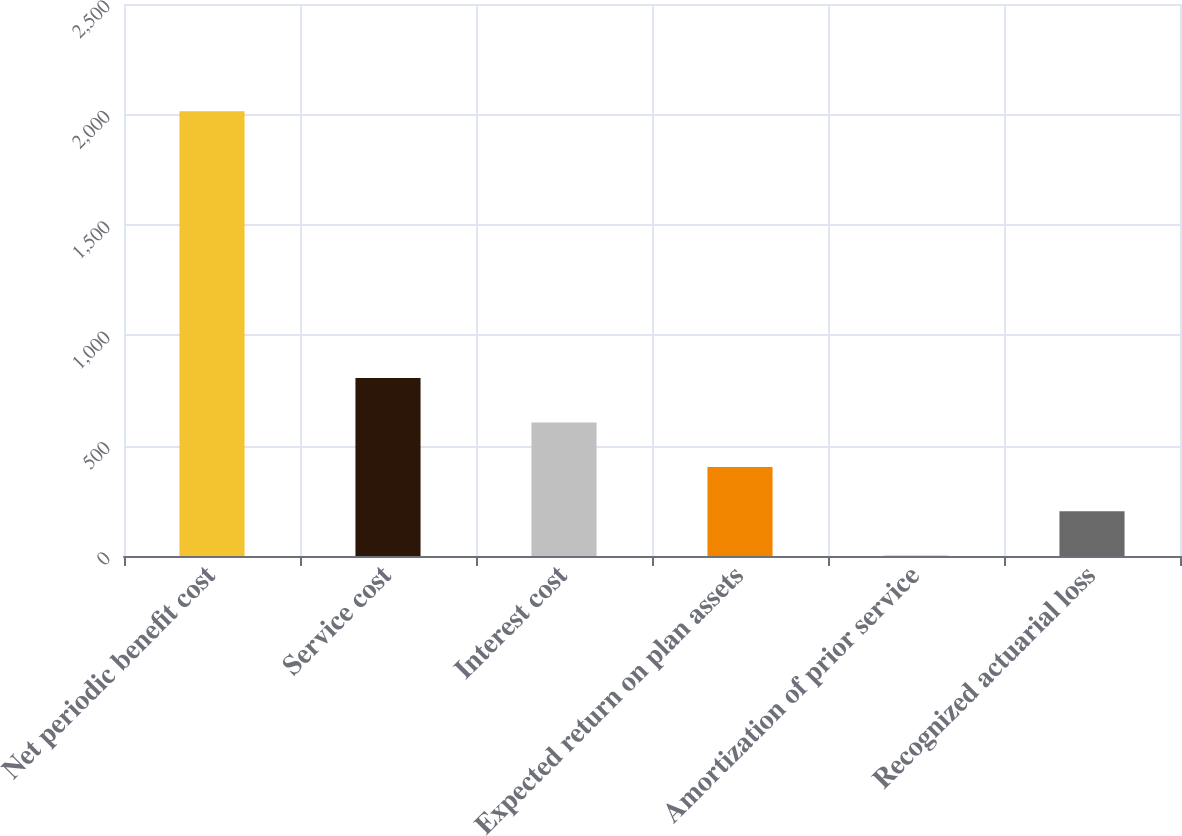<chart> <loc_0><loc_0><loc_500><loc_500><bar_chart><fcel>Net periodic benefit cost<fcel>Service cost<fcel>Interest cost<fcel>Expected return on plan assets<fcel>Amortization of prior service<fcel>Recognized actuarial loss<nl><fcel>2014<fcel>806.2<fcel>604.9<fcel>403.6<fcel>1<fcel>202.3<nl></chart> 